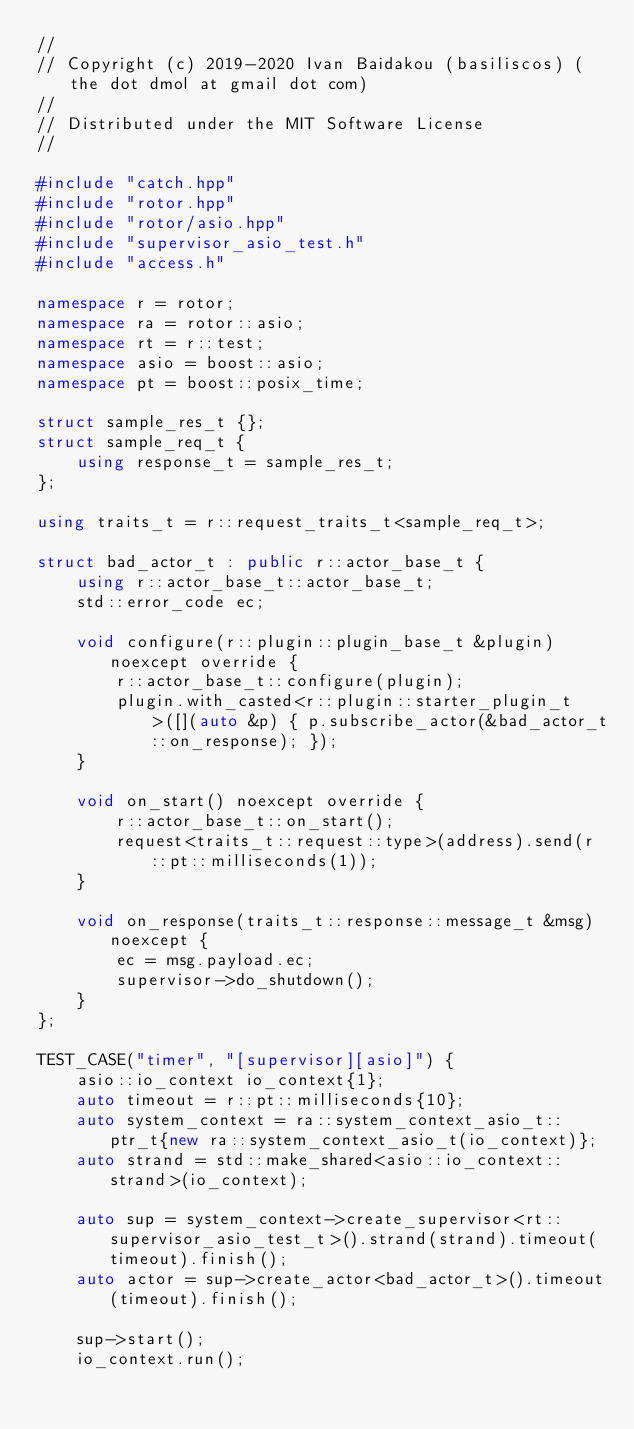<code> <loc_0><loc_0><loc_500><loc_500><_C++_>//
// Copyright (c) 2019-2020 Ivan Baidakou (basiliscos) (the dot dmol at gmail dot com)
//
// Distributed under the MIT Software License
//

#include "catch.hpp"
#include "rotor.hpp"
#include "rotor/asio.hpp"
#include "supervisor_asio_test.h"
#include "access.h"

namespace r = rotor;
namespace ra = rotor::asio;
namespace rt = r::test;
namespace asio = boost::asio;
namespace pt = boost::posix_time;

struct sample_res_t {};
struct sample_req_t {
    using response_t = sample_res_t;
};

using traits_t = r::request_traits_t<sample_req_t>;

struct bad_actor_t : public r::actor_base_t {
    using r::actor_base_t::actor_base_t;
    std::error_code ec;

    void configure(r::plugin::plugin_base_t &plugin) noexcept override {
        r::actor_base_t::configure(plugin);
        plugin.with_casted<r::plugin::starter_plugin_t>([](auto &p) { p.subscribe_actor(&bad_actor_t::on_response); });
    }

    void on_start() noexcept override {
        r::actor_base_t::on_start();
        request<traits_t::request::type>(address).send(r::pt::milliseconds(1));
    }

    void on_response(traits_t::response::message_t &msg) noexcept {
        ec = msg.payload.ec;
        supervisor->do_shutdown();
    }
};

TEST_CASE("timer", "[supervisor][asio]") {
    asio::io_context io_context{1};
    auto timeout = r::pt::milliseconds{10};
    auto system_context = ra::system_context_asio_t::ptr_t{new ra::system_context_asio_t(io_context)};
    auto strand = std::make_shared<asio::io_context::strand>(io_context);

    auto sup = system_context->create_supervisor<rt::supervisor_asio_test_t>().strand(strand).timeout(timeout).finish();
    auto actor = sup->create_actor<bad_actor_t>().timeout(timeout).finish();

    sup->start();
    io_context.run();
</code> 